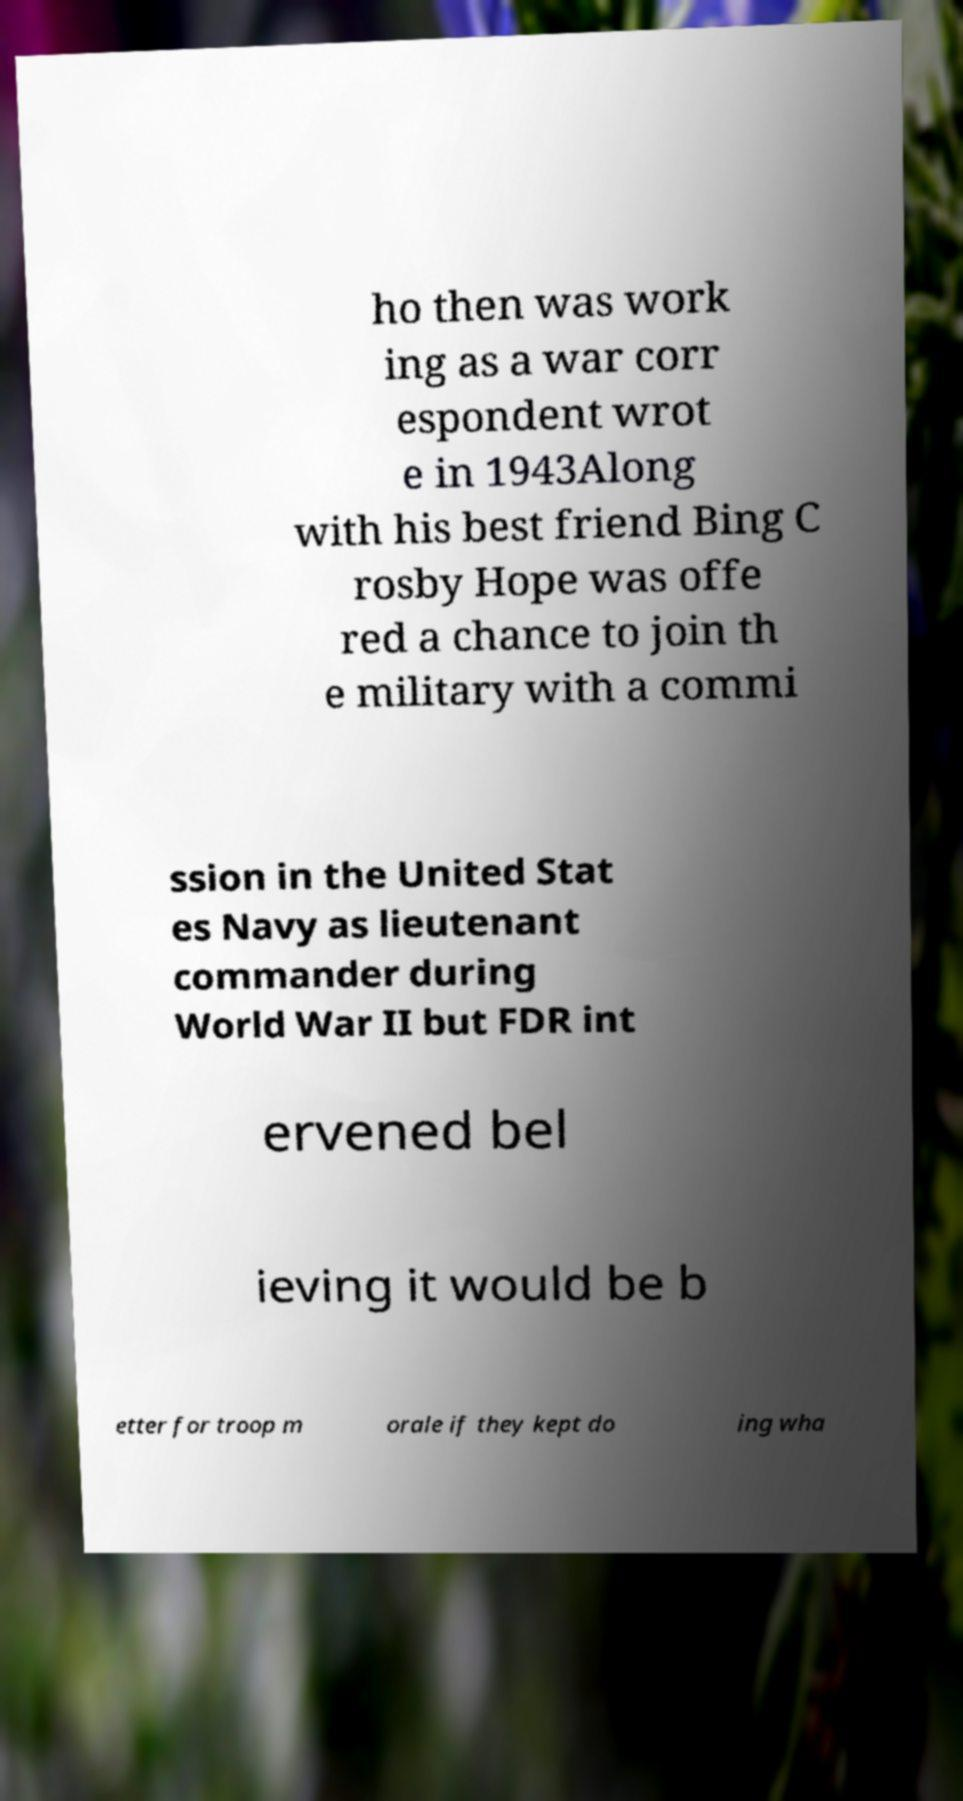What messages or text are displayed in this image? I need them in a readable, typed format. ho then was work ing as a war corr espondent wrot e in 1943Along with his best friend Bing C rosby Hope was offe red a chance to join th e military with a commi ssion in the United Stat es Navy as lieutenant commander during World War II but FDR int ervened bel ieving it would be b etter for troop m orale if they kept do ing wha 